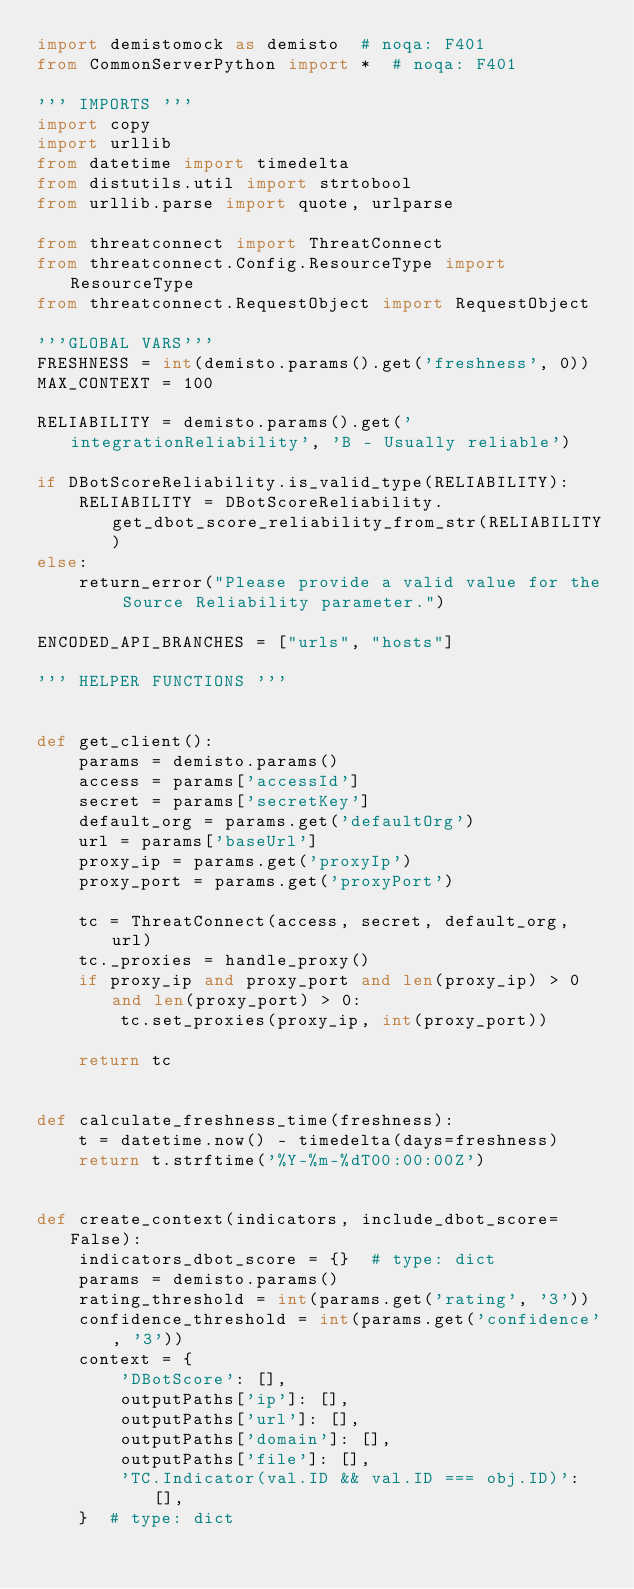<code> <loc_0><loc_0><loc_500><loc_500><_Python_>import demistomock as demisto  # noqa: F401
from CommonServerPython import *  # noqa: F401

''' IMPORTS '''
import copy
import urllib
from datetime import timedelta
from distutils.util import strtobool
from urllib.parse import quote, urlparse

from threatconnect import ThreatConnect
from threatconnect.Config.ResourceType import ResourceType
from threatconnect.RequestObject import RequestObject

'''GLOBAL VARS'''
FRESHNESS = int(demisto.params().get('freshness', 0))
MAX_CONTEXT = 100

RELIABILITY = demisto.params().get('integrationReliability', 'B - Usually reliable')

if DBotScoreReliability.is_valid_type(RELIABILITY):
    RELIABILITY = DBotScoreReliability.get_dbot_score_reliability_from_str(RELIABILITY)
else:
    return_error("Please provide a valid value for the Source Reliability parameter.")

ENCODED_API_BRANCHES = ["urls", "hosts"]

''' HELPER FUNCTIONS '''


def get_client():
    params = demisto.params()
    access = params['accessId']
    secret = params['secretKey']
    default_org = params.get('defaultOrg')
    url = params['baseUrl']
    proxy_ip = params.get('proxyIp')
    proxy_port = params.get('proxyPort')

    tc = ThreatConnect(access, secret, default_org, url)
    tc._proxies = handle_proxy()
    if proxy_ip and proxy_port and len(proxy_ip) > 0 and len(proxy_port) > 0:
        tc.set_proxies(proxy_ip, int(proxy_port))

    return tc


def calculate_freshness_time(freshness):
    t = datetime.now() - timedelta(days=freshness)
    return t.strftime('%Y-%m-%dT00:00:00Z')


def create_context(indicators, include_dbot_score=False):
    indicators_dbot_score = {}  # type: dict
    params = demisto.params()
    rating_threshold = int(params.get('rating', '3'))
    confidence_threshold = int(params.get('confidence', '3'))
    context = {
        'DBotScore': [],
        outputPaths['ip']: [],
        outputPaths['url']: [],
        outputPaths['domain']: [],
        outputPaths['file']: [],
        'TC.Indicator(val.ID && val.ID === obj.ID)': [],
    }  # type: dict</code> 